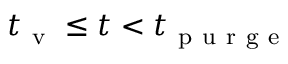<formula> <loc_0><loc_0><loc_500><loc_500>t _ { v } \leq t < t _ { p u r g e }</formula> 